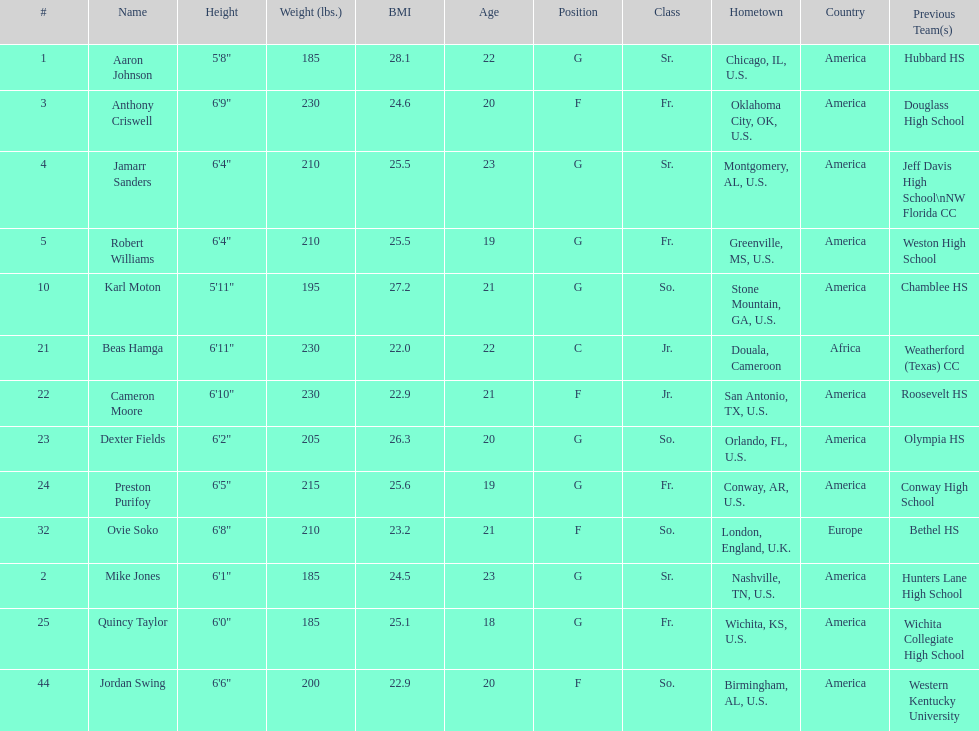What is the difference in weight between dexter fields and quincy taylor? 20. 